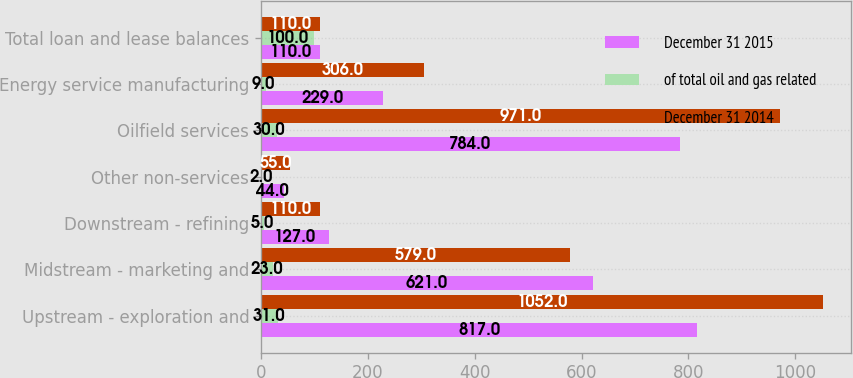Convert chart to OTSL. <chart><loc_0><loc_0><loc_500><loc_500><stacked_bar_chart><ecel><fcel>Upstream - exploration and<fcel>Midstream - marketing and<fcel>Downstream - refining<fcel>Other non-services<fcel>Oilfield services<fcel>Energy service manufacturing<fcel>Total loan and lease balances<nl><fcel>December 31 2015<fcel>817<fcel>621<fcel>127<fcel>44<fcel>784<fcel>229<fcel>110<nl><fcel>of total oil and gas related<fcel>31<fcel>23<fcel>5<fcel>2<fcel>30<fcel>9<fcel>100<nl><fcel>December 31 2014<fcel>1052<fcel>579<fcel>110<fcel>55<fcel>971<fcel>306<fcel>110<nl></chart> 